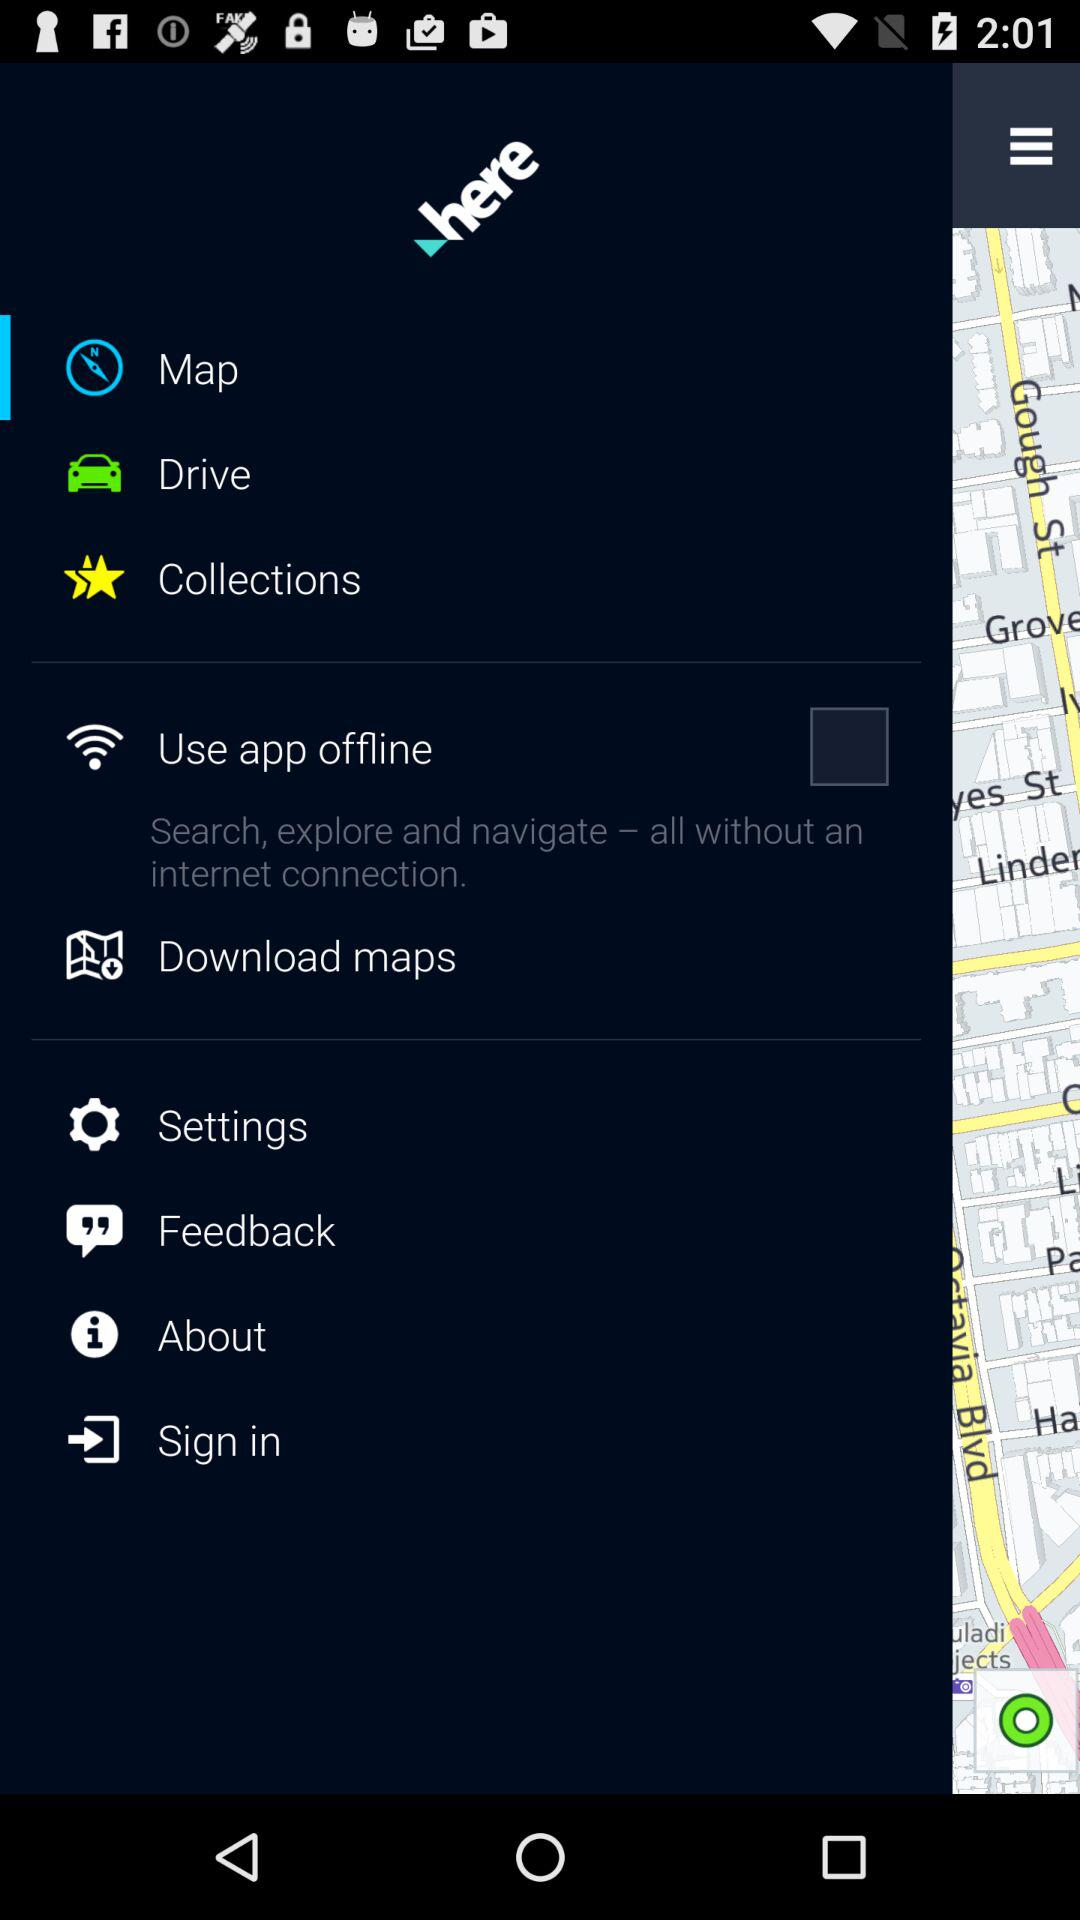What is the status of "Use app offline"? The status is off. 